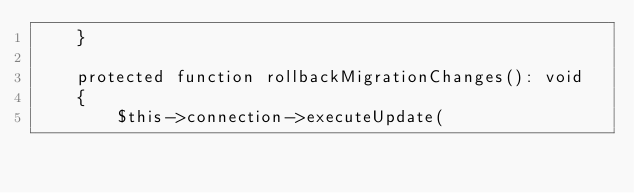<code> <loc_0><loc_0><loc_500><loc_500><_PHP_>    }

    protected function rollbackMigrationChanges(): void
    {
        $this->connection->executeUpdate(</code> 